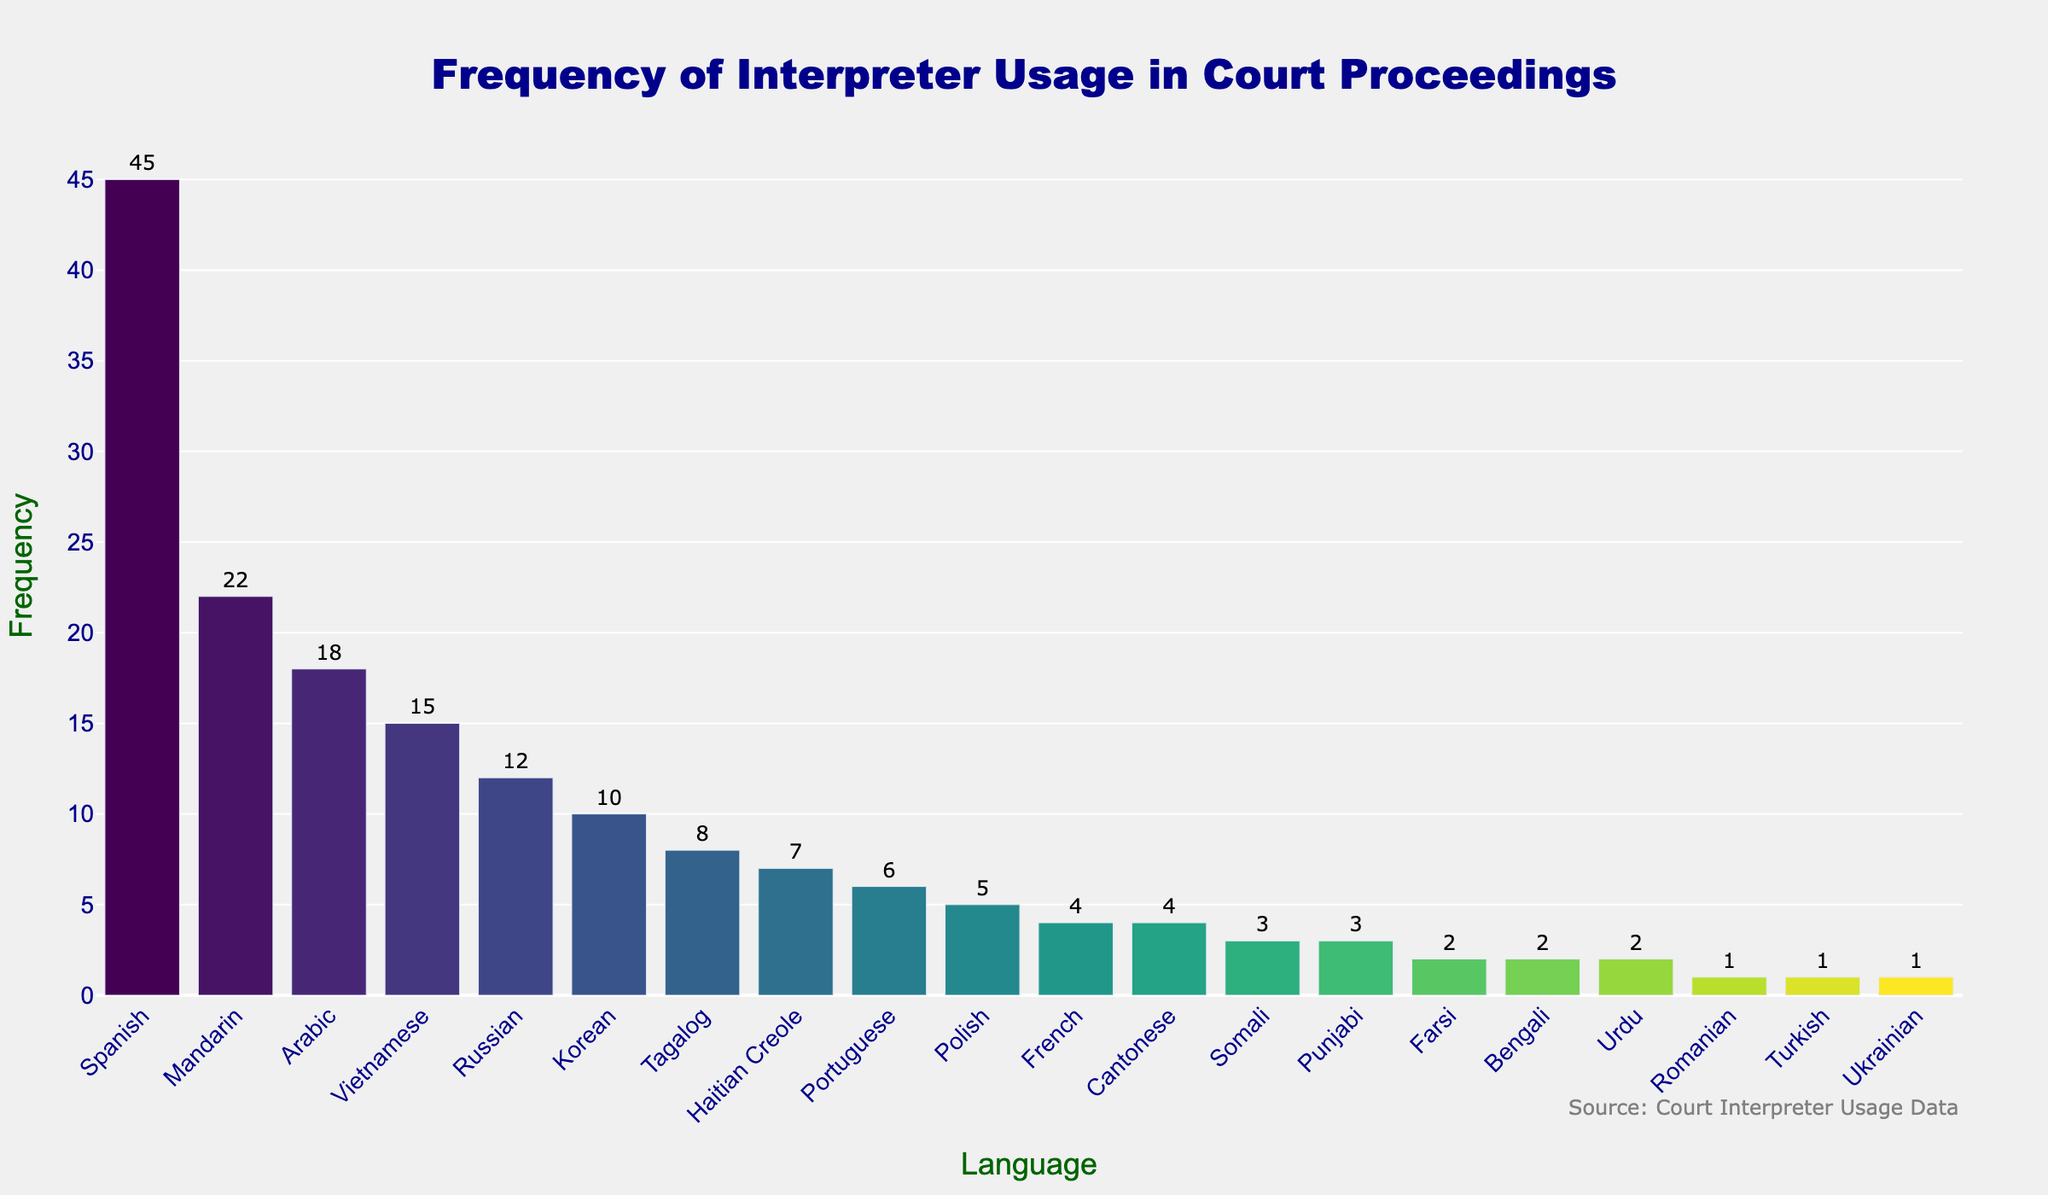What is the most frequently used language for interpreter services in court proceedings? The chart shows different languages along with their frequency of interpreter usage. The highest bar corresponds to the most frequently used language. Spanish has the highest bar with a frequency of 45.
Answer: Spanish Which language has a frequency of 22 in interpreter usage? By checking the chart, the bar for Mandarin is labeled with a frequency of 22.
Answer: Mandarin How many more times is Spanish used compared to Russian for interpreter services? The frequency for Spanish is 45, and for Russian, it is 12. The difference is calculated as 45 - 12.
Answer: 33 List all languages that have a frequency of 5 or less. Looking at the bars, we identify languages with frequencies less than or equal to 5: Polish (5), Cantonese (4), French (4), Somali (3), Punjabi (3), Farsi (2), Bengali (2), Urdu (2), Romanian (1), Turkish (1), and Ukrainian (1).
Answer: Polish, Cantonese, French, Somali, Punjabi, Farsi, Bengali, Urdu, Romanian, Turkish, Ukrainian Which language has the lowest frequency, and what is that frequency? The shortest bars represent the lowest frequencies. Romanian, Turkish, and Ukrainian each have the lowest frequency of 1.
Answer: Romanian, Turkish, Ukrainian How many languages have a frequency greater than or equal to 10? Counting the bars with frequencies 10 or higher: Spanish, Mandarin, Arabic, Vietnamese, Russian, and Korean. There are 6 such languages.
Answer: 6 What is the combined frequency of interpreter usage for French and Cantonese? French has a frequency of 4, and Cantonese also has a frequency of 4. Summing them up, 4 + 4 = 8.
Answer: 8 How many languages have interpreter usage frequencies that are prime numbers? Identifying prime numbers within the frequencies: 2 (Farsi, Bengali, Urdu), 3 (Somali, Punjabi), 5 (Polish), 7 (Haitian Creole), 11 (none), 13 (none), 17 (none), 19 (none), 23 (none). There are 7 such frequencies: 2, 3, 5, 7.
Answer: 7 